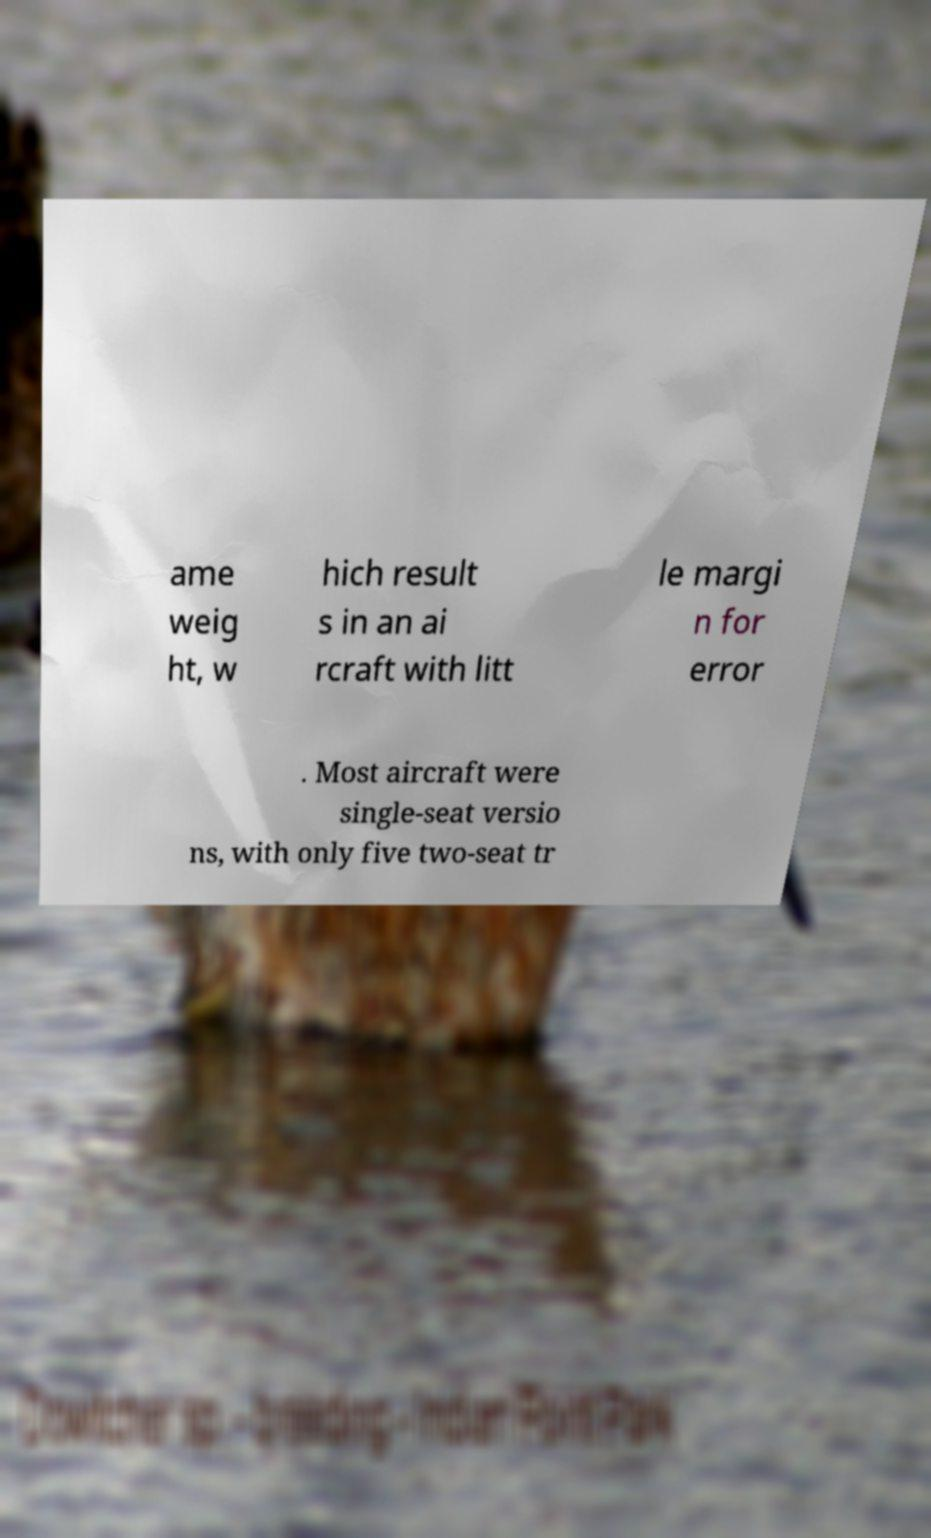Can you read and provide the text displayed in the image?This photo seems to have some interesting text. Can you extract and type it out for me? ame weig ht, w hich result s in an ai rcraft with litt le margi n for error . Most aircraft were single-seat versio ns, with only five two-seat tr 